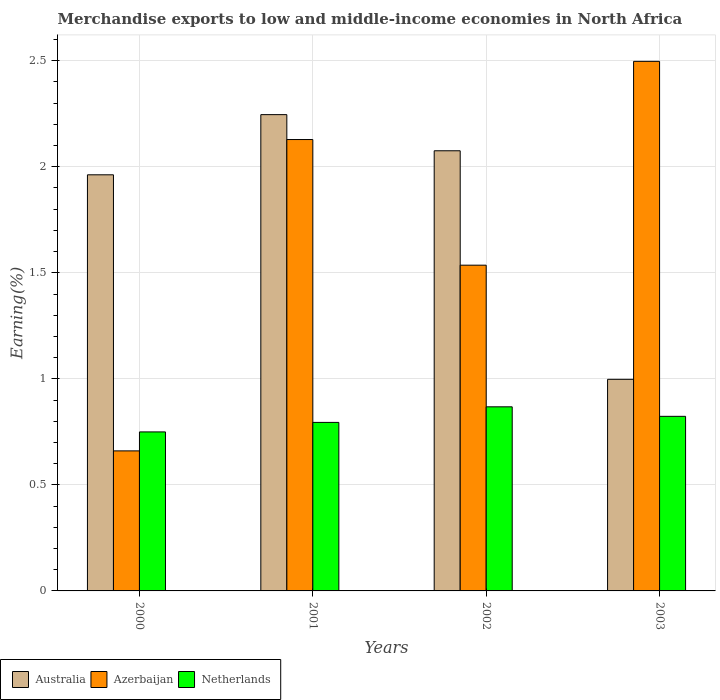Are the number of bars per tick equal to the number of legend labels?
Ensure brevity in your answer.  Yes. How many bars are there on the 2nd tick from the left?
Your answer should be very brief. 3. How many bars are there on the 3rd tick from the right?
Offer a very short reply. 3. What is the label of the 3rd group of bars from the left?
Your answer should be compact. 2002. In how many cases, is the number of bars for a given year not equal to the number of legend labels?
Offer a very short reply. 0. What is the percentage of amount earned from merchandise exports in Azerbaijan in 2000?
Your answer should be very brief. 0.66. Across all years, what is the maximum percentage of amount earned from merchandise exports in Azerbaijan?
Your answer should be very brief. 2.5. Across all years, what is the minimum percentage of amount earned from merchandise exports in Azerbaijan?
Your answer should be compact. 0.66. In which year was the percentage of amount earned from merchandise exports in Netherlands minimum?
Provide a short and direct response. 2000. What is the total percentage of amount earned from merchandise exports in Netherlands in the graph?
Your answer should be very brief. 3.24. What is the difference between the percentage of amount earned from merchandise exports in Netherlands in 2001 and that in 2003?
Make the answer very short. -0.03. What is the difference between the percentage of amount earned from merchandise exports in Australia in 2000 and the percentage of amount earned from merchandise exports in Azerbaijan in 2003?
Provide a succinct answer. -0.54. What is the average percentage of amount earned from merchandise exports in Azerbaijan per year?
Keep it short and to the point. 1.71. In the year 2002, what is the difference between the percentage of amount earned from merchandise exports in Azerbaijan and percentage of amount earned from merchandise exports in Australia?
Keep it short and to the point. -0.54. In how many years, is the percentage of amount earned from merchandise exports in Azerbaijan greater than 1.1 %?
Provide a short and direct response. 3. What is the ratio of the percentage of amount earned from merchandise exports in Netherlands in 2002 to that in 2003?
Offer a very short reply. 1.05. Is the difference between the percentage of amount earned from merchandise exports in Azerbaijan in 2000 and 2003 greater than the difference between the percentage of amount earned from merchandise exports in Australia in 2000 and 2003?
Offer a very short reply. No. What is the difference between the highest and the second highest percentage of amount earned from merchandise exports in Australia?
Keep it short and to the point. 0.17. What is the difference between the highest and the lowest percentage of amount earned from merchandise exports in Azerbaijan?
Your answer should be very brief. 1.84. In how many years, is the percentage of amount earned from merchandise exports in Netherlands greater than the average percentage of amount earned from merchandise exports in Netherlands taken over all years?
Make the answer very short. 2. What does the 1st bar from the left in 2003 represents?
Your answer should be very brief. Australia. Is it the case that in every year, the sum of the percentage of amount earned from merchandise exports in Azerbaijan and percentage of amount earned from merchandise exports in Australia is greater than the percentage of amount earned from merchandise exports in Netherlands?
Provide a short and direct response. Yes. Are all the bars in the graph horizontal?
Ensure brevity in your answer.  No. How many years are there in the graph?
Make the answer very short. 4. What is the difference between two consecutive major ticks on the Y-axis?
Provide a short and direct response. 0.5. Does the graph contain any zero values?
Provide a succinct answer. No. Does the graph contain grids?
Offer a terse response. Yes. What is the title of the graph?
Give a very brief answer. Merchandise exports to low and middle-income economies in North Africa. What is the label or title of the Y-axis?
Offer a terse response. Earning(%). What is the Earning(%) in Australia in 2000?
Your answer should be very brief. 1.96. What is the Earning(%) of Azerbaijan in 2000?
Your response must be concise. 0.66. What is the Earning(%) in Netherlands in 2000?
Your answer should be compact. 0.75. What is the Earning(%) of Australia in 2001?
Offer a terse response. 2.25. What is the Earning(%) in Azerbaijan in 2001?
Offer a terse response. 2.13. What is the Earning(%) of Netherlands in 2001?
Give a very brief answer. 0.79. What is the Earning(%) of Australia in 2002?
Provide a short and direct response. 2.08. What is the Earning(%) in Azerbaijan in 2002?
Your response must be concise. 1.54. What is the Earning(%) in Netherlands in 2002?
Offer a terse response. 0.87. What is the Earning(%) of Australia in 2003?
Ensure brevity in your answer.  1. What is the Earning(%) in Azerbaijan in 2003?
Make the answer very short. 2.5. What is the Earning(%) of Netherlands in 2003?
Ensure brevity in your answer.  0.82. Across all years, what is the maximum Earning(%) of Australia?
Make the answer very short. 2.25. Across all years, what is the maximum Earning(%) in Azerbaijan?
Give a very brief answer. 2.5. Across all years, what is the maximum Earning(%) in Netherlands?
Keep it short and to the point. 0.87. Across all years, what is the minimum Earning(%) of Australia?
Your answer should be compact. 1. Across all years, what is the minimum Earning(%) of Azerbaijan?
Ensure brevity in your answer.  0.66. Across all years, what is the minimum Earning(%) in Netherlands?
Provide a succinct answer. 0.75. What is the total Earning(%) in Australia in the graph?
Your response must be concise. 7.28. What is the total Earning(%) in Azerbaijan in the graph?
Offer a terse response. 6.82. What is the total Earning(%) of Netherlands in the graph?
Provide a succinct answer. 3.24. What is the difference between the Earning(%) in Australia in 2000 and that in 2001?
Make the answer very short. -0.28. What is the difference between the Earning(%) of Azerbaijan in 2000 and that in 2001?
Provide a succinct answer. -1.47. What is the difference between the Earning(%) in Netherlands in 2000 and that in 2001?
Keep it short and to the point. -0.04. What is the difference between the Earning(%) of Australia in 2000 and that in 2002?
Offer a very short reply. -0.11. What is the difference between the Earning(%) in Azerbaijan in 2000 and that in 2002?
Your response must be concise. -0.88. What is the difference between the Earning(%) in Netherlands in 2000 and that in 2002?
Offer a terse response. -0.12. What is the difference between the Earning(%) in Australia in 2000 and that in 2003?
Ensure brevity in your answer.  0.96. What is the difference between the Earning(%) of Azerbaijan in 2000 and that in 2003?
Offer a terse response. -1.84. What is the difference between the Earning(%) in Netherlands in 2000 and that in 2003?
Provide a short and direct response. -0.07. What is the difference between the Earning(%) in Australia in 2001 and that in 2002?
Make the answer very short. 0.17. What is the difference between the Earning(%) in Azerbaijan in 2001 and that in 2002?
Keep it short and to the point. 0.59. What is the difference between the Earning(%) in Netherlands in 2001 and that in 2002?
Offer a very short reply. -0.07. What is the difference between the Earning(%) of Australia in 2001 and that in 2003?
Make the answer very short. 1.25. What is the difference between the Earning(%) of Azerbaijan in 2001 and that in 2003?
Offer a very short reply. -0.37. What is the difference between the Earning(%) in Netherlands in 2001 and that in 2003?
Offer a very short reply. -0.03. What is the difference between the Earning(%) in Australia in 2002 and that in 2003?
Offer a very short reply. 1.08. What is the difference between the Earning(%) in Azerbaijan in 2002 and that in 2003?
Provide a short and direct response. -0.96. What is the difference between the Earning(%) of Netherlands in 2002 and that in 2003?
Your answer should be very brief. 0.04. What is the difference between the Earning(%) of Australia in 2000 and the Earning(%) of Azerbaijan in 2001?
Offer a terse response. -0.17. What is the difference between the Earning(%) in Australia in 2000 and the Earning(%) in Netherlands in 2001?
Ensure brevity in your answer.  1.17. What is the difference between the Earning(%) of Azerbaijan in 2000 and the Earning(%) of Netherlands in 2001?
Offer a very short reply. -0.13. What is the difference between the Earning(%) in Australia in 2000 and the Earning(%) in Azerbaijan in 2002?
Ensure brevity in your answer.  0.43. What is the difference between the Earning(%) of Australia in 2000 and the Earning(%) of Netherlands in 2002?
Ensure brevity in your answer.  1.09. What is the difference between the Earning(%) of Azerbaijan in 2000 and the Earning(%) of Netherlands in 2002?
Provide a succinct answer. -0.21. What is the difference between the Earning(%) in Australia in 2000 and the Earning(%) in Azerbaijan in 2003?
Ensure brevity in your answer.  -0.54. What is the difference between the Earning(%) of Australia in 2000 and the Earning(%) of Netherlands in 2003?
Offer a terse response. 1.14. What is the difference between the Earning(%) in Azerbaijan in 2000 and the Earning(%) in Netherlands in 2003?
Offer a very short reply. -0.16. What is the difference between the Earning(%) of Australia in 2001 and the Earning(%) of Azerbaijan in 2002?
Provide a short and direct response. 0.71. What is the difference between the Earning(%) in Australia in 2001 and the Earning(%) in Netherlands in 2002?
Keep it short and to the point. 1.38. What is the difference between the Earning(%) of Azerbaijan in 2001 and the Earning(%) of Netherlands in 2002?
Your answer should be very brief. 1.26. What is the difference between the Earning(%) of Australia in 2001 and the Earning(%) of Azerbaijan in 2003?
Ensure brevity in your answer.  -0.25. What is the difference between the Earning(%) in Australia in 2001 and the Earning(%) in Netherlands in 2003?
Your response must be concise. 1.42. What is the difference between the Earning(%) in Azerbaijan in 2001 and the Earning(%) in Netherlands in 2003?
Offer a very short reply. 1.31. What is the difference between the Earning(%) of Australia in 2002 and the Earning(%) of Azerbaijan in 2003?
Offer a very short reply. -0.42. What is the difference between the Earning(%) in Australia in 2002 and the Earning(%) in Netherlands in 2003?
Ensure brevity in your answer.  1.25. What is the difference between the Earning(%) in Azerbaijan in 2002 and the Earning(%) in Netherlands in 2003?
Offer a very short reply. 0.71. What is the average Earning(%) in Australia per year?
Give a very brief answer. 1.82. What is the average Earning(%) in Azerbaijan per year?
Your answer should be very brief. 1.71. What is the average Earning(%) of Netherlands per year?
Keep it short and to the point. 0.81. In the year 2000, what is the difference between the Earning(%) of Australia and Earning(%) of Azerbaijan?
Offer a terse response. 1.3. In the year 2000, what is the difference between the Earning(%) in Australia and Earning(%) in Netherlands?
Make the answer very short. 1.21. In the year 2000, what is the difference between the Earning(%) of Azerbaijan and Earning(%) of Netherlands?
Your answer should be compact. -0.09. In the year 2001, what is the difference between the Earning(%) in Australia and Earning(%) in Azerbaijan?
Give a very brief answer. 0.12. In the year 2001, what is the difference between the Earning(%) of Australia and Earning(%) of Netherlands?
Your answer should be compact. 1.45. In the year 2001, what is the difference between the Earning(%) in Azerbaijan and Earning(%) in Netherlands?
Your answer should be compact. 1.33. In the year 2002, what is the difference between the Earning(%) in Australia and Earning(%) in Azerbaijan?
Ensure brevity in your answer.  0.54. In the year 2002, what is the difference between the Earning(%) of Australia and Earning(%) of Netherlands?
Your response must be concise. 1.21. In the year 2002, what is the difference between the Earning(%) in Azerbaijan and Earning(%) in Netherlands?
Make the answer very short. 0.67. In the year 2003, what is the difference between the Earning(%) in Australia and Earning(%) in Azerbaijan?
Give a very brief answer. -1.5. In the year 2003, what is the difference between the Earning(%) of Australia and Earning(%) of Netherlands?
Offer a terse response. 0.17. In the year 2003, what is the difference between the Earning(%) in Azerbaijan and Earning(%) in Netherlands?
Offer a terse response. 1.67. What is the ratio of the Earning(%) of Australia in 2000 to that in 2001?
Provide a short and direct response. 0.87. What is the ratio of the Earning(%) of Azerbaijan in 2000 to that in 2001?
Offer a terse response. 0.31. What is the ratio of the Earning(%) in Netherlands in 2000 to that in 2001?
Your response must be concise. 0.94. What is the ratio of the Earning(%) of Australia in 2000 to that in 2002?
Provide a short and direct response. 0.95. What is the ratio of the Earning(%) of Azerbaijan in 2000 to that in 2002?
Your response must be concise. 0.43. What is the ratio of the Earning(%) in Netherlands in 2000 to that in 2002?
Provide a succinct answer. 0.86. What is the ratio of the Earning(%) of Australia in 2000 to that in 2003?
Ensure brevity in your answer.  1.97. What is the ratio of the Earning(%) of Azerbaijan in 2000 to that in 2003?
Your response must be concise. 0.26. What is the ratio of the Earning(%) in Netherlands in 2000 to that in 2003?
Provide a short and direct response. 0.91. What is the ratio of the Earning(%) in Australia in 2001 to that in 2002?
Offer a terse response. 1.08. What is the ratio of the Earning(%) of Azerbaijan in 2001 to that in 2002?
Keep it short and to the point. 1.39. What is the ratio of the Earning(%) in Netherlands in 2001 to that in 2002?
Offer a terse response. 0.92. What is the ratio of the Earning(%) in Australia in 2001 to that in 2003?
Make the answer very short. 2.25. What is the ratio of the Earning(%) in Azerbaijan in 2001 to that in 2003?
Your response must be concise. 0.85. What is the ratio of the Earning(%) of Netherlands in 2001 to that in 2003?
Offer a very short reply. 0.97. What is the ratio of the Earning(%) of Australia in 2002 to that in 2003?
Offer a very short reply. 2.08. What is the ratio of the Earning(%) in Azerbaijan in 2002 to that in 2003?
Offer a very short reply. 0.62. What is the ratio of the Earning(%) in Netherlands in 2002 to that in 2003?
Give a very brief answer. 1.05. What is the difference between the highest and the second highest Earning(%) of Australia?
Provide a succinct answer. 0.17. What is the difference between the highest and the second highest Earning(%) of Azerbaijan?
Your response must be concise. 0.37. What is the difference between the highest and the second highest Earning(%) of Netherlands?
Provide a succinct answer. 0.04. What is the difference between the highest and the lowest Earning(%) in Australia?
Your answer should be very brief. 1.25. What is the difference between the highest and the lowest Earning(%) in Azerbaijan?
Make the answer very short. 1.84. What is the difference between the highest and the lowest Earning(%) in Netherlands?
Ensure brevity in your answer.  0.12. 